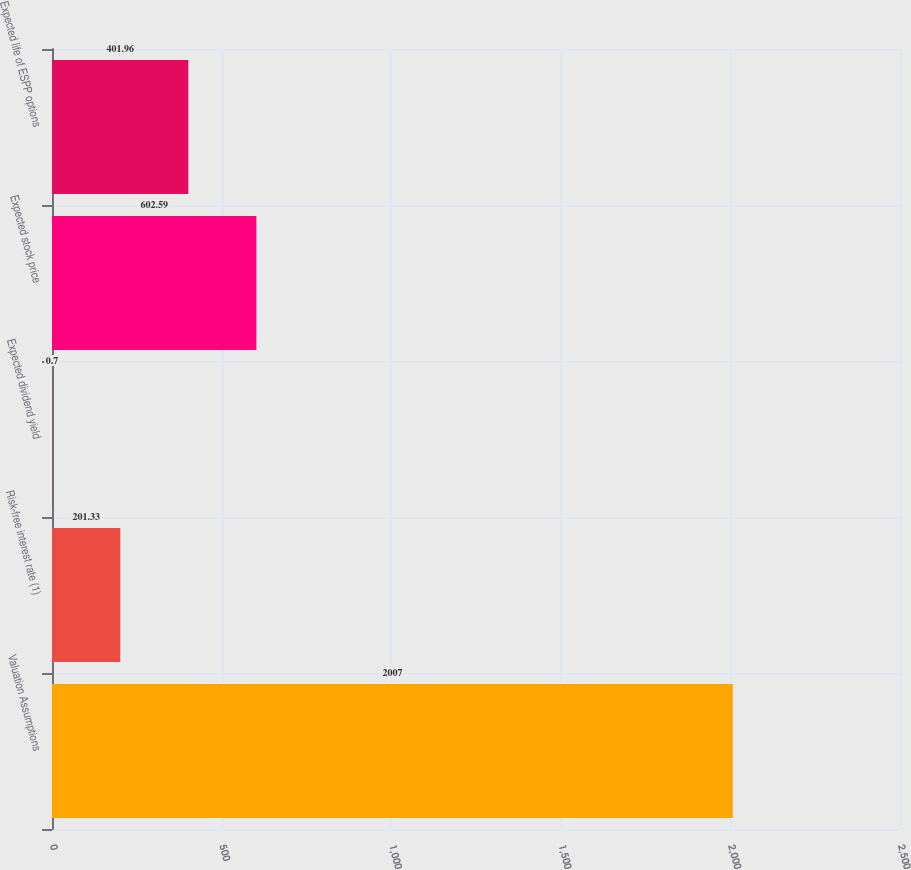Convert chart to OTSL. <chart><loc_0><loc_0><loc_500><loc_500><bar_chart><fcel>Valuation Assumptions<fcel>Risk-free interest rate (1)<fcel>Expected dividend yield<fcel>Expected stock price<fcel>Expected life of ESPP options<nl><fcel>2007<fcel>201.33<fcel>0.7<fcel>602.59<fcel>401.96<nl></chart> 